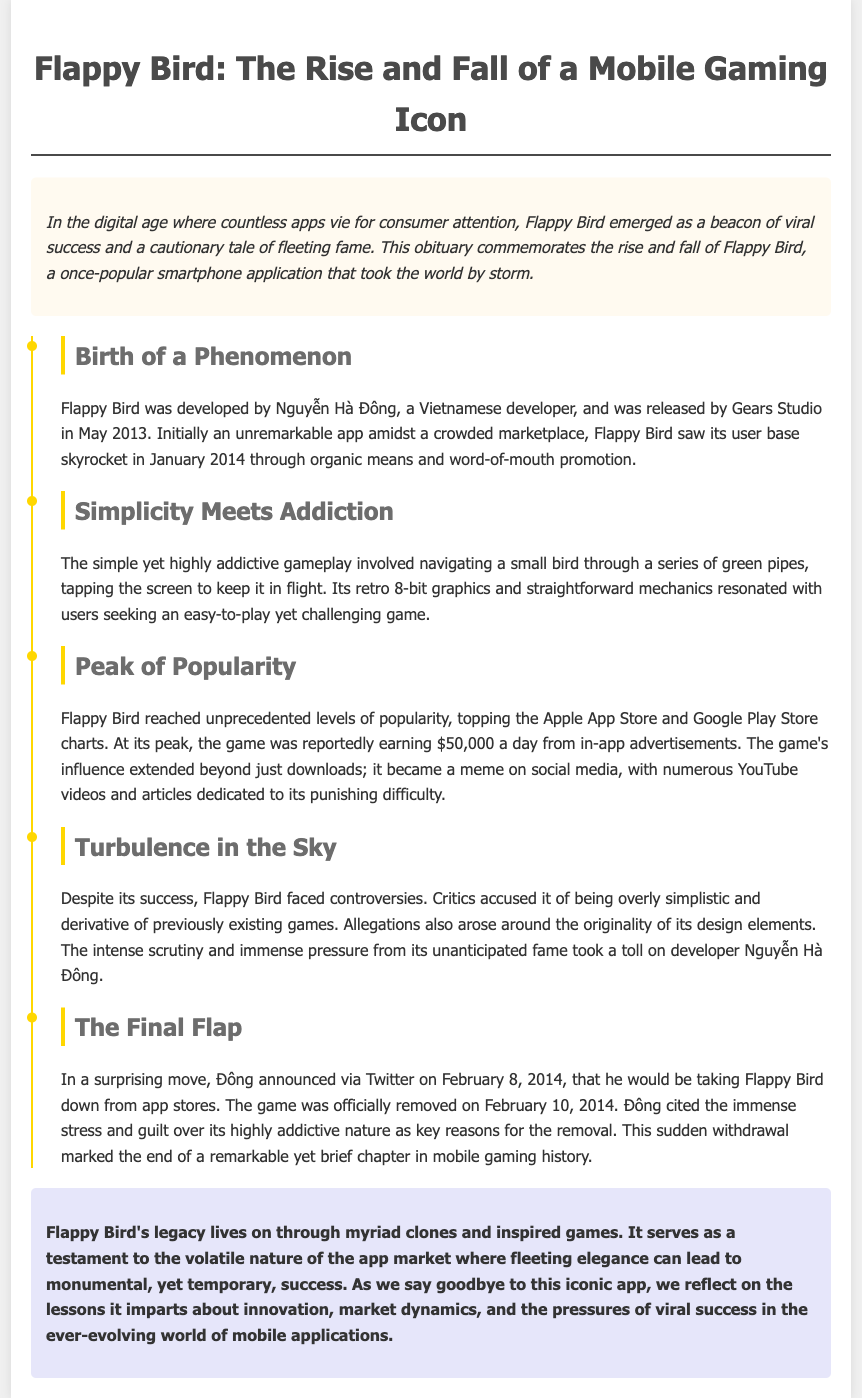What year was Flappy Bird released? The document states that Flappy Bird was released in May 2013.
Answer: May 2013 How much was Flappy Bird reportedly earning daily at its peak? According to the document, the game was reportedly earning $50,000 a day at its peak.
Answer: $50,000 Who developed Flappy Bird? The document mentions that Flappy Bird was developed by Nguyễn Hà Đông.
Answer: Nguyễn Hà Đông When did Flappy Bird get removed from app stores? The document specifies that Flappy Bird was officially removed on February 10, 2014.
Answer: February 10, 2014 What was a notable feature of Flappy Bird's gameplay? The document highlights that the gameplay involved navigating a small bird through a series of green pipes.
Answer: Navigating a small bird through green pipes What reason did the developer give for removing Flappy Bird? The document notes that Đông cited immense stress and guilt over its highly addictive nature as reasons for removal.
Answer: Immense stress and guilt over its highly addictive nature What significant impact did Flappy Bird have on social media? The document states that the game became a meme on social media with numerous YouTube videos and articles dedicated to it.
Answer: Became a meme on social media What does Flappy Bird's legacy reflect on? The document concludes that Flappy Bird's legacy reflects on the volatile nature of the app market.
Answer: The volatile nature of the app market 